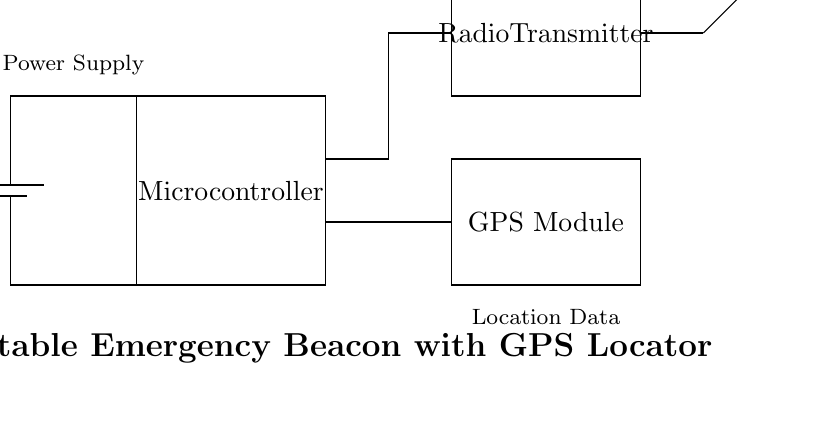What is the voltage of the power supply? The circuit diagram shows a battery labeled with a voltage of 3.7V, indicating that this is the voltage provided to the circuit.
Answer: 3.7 volts What component receives location data? In the circuit, the GPS module is specifically labeled to receive and process location data, making it the component responsible for this function.
Answer: GPS Module How does the power supply connect to the microcontroller? The power supply is connected to the microcontroller by a direct line, indicating that it provides the necessary power for the microcontroller to function.
Answer: Direct connection What type of signal does the radio transmitter send? The diagram indicates that the radio transmitter is associated with sending an "Emergency Signal," highlighting its role within the circuit for safety communication.
Answer: Emergency Signal What components are involved in transmitting your location? The location data is processed by the GPS module and then sent via the radio transmitter, which operates in conjunction within the circuit to communicate the user's location.
Answer: GPS Module and Radio Transmitter How does the GPS module connect to the microcontroller? The GPS module connects to the microcontroller with a line that shows a direct relationship, indicating that the microcontroller receives processed location data from the GPS module.
Answer: Direct connection 